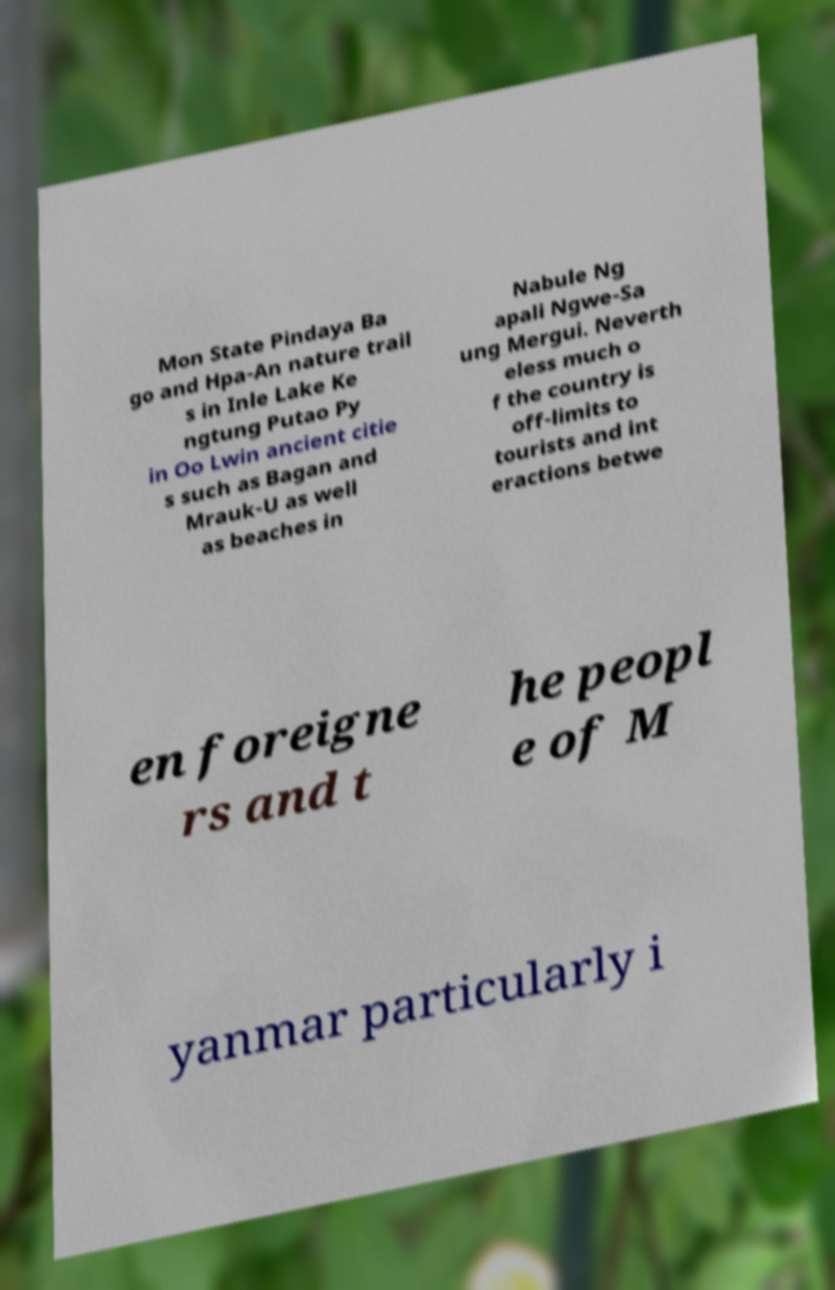There's text embedded in this image that I need extracted. Can you transcribe it verbatim? Mon State Pindaya Ba go and Hpa-An nature trail s in Inle Lake Ke ngtung Putao Py in Oo Lwin ancient citie s such as Bagan and Mrauk-U as well as beaches in Nabule Ng apali Ngwe-Sa ung Mergui. Neverth eless much o f the country is off-limits to tourists and int eractions betwe en foreigne rs and t he peopl e of M yanmar particularly i 